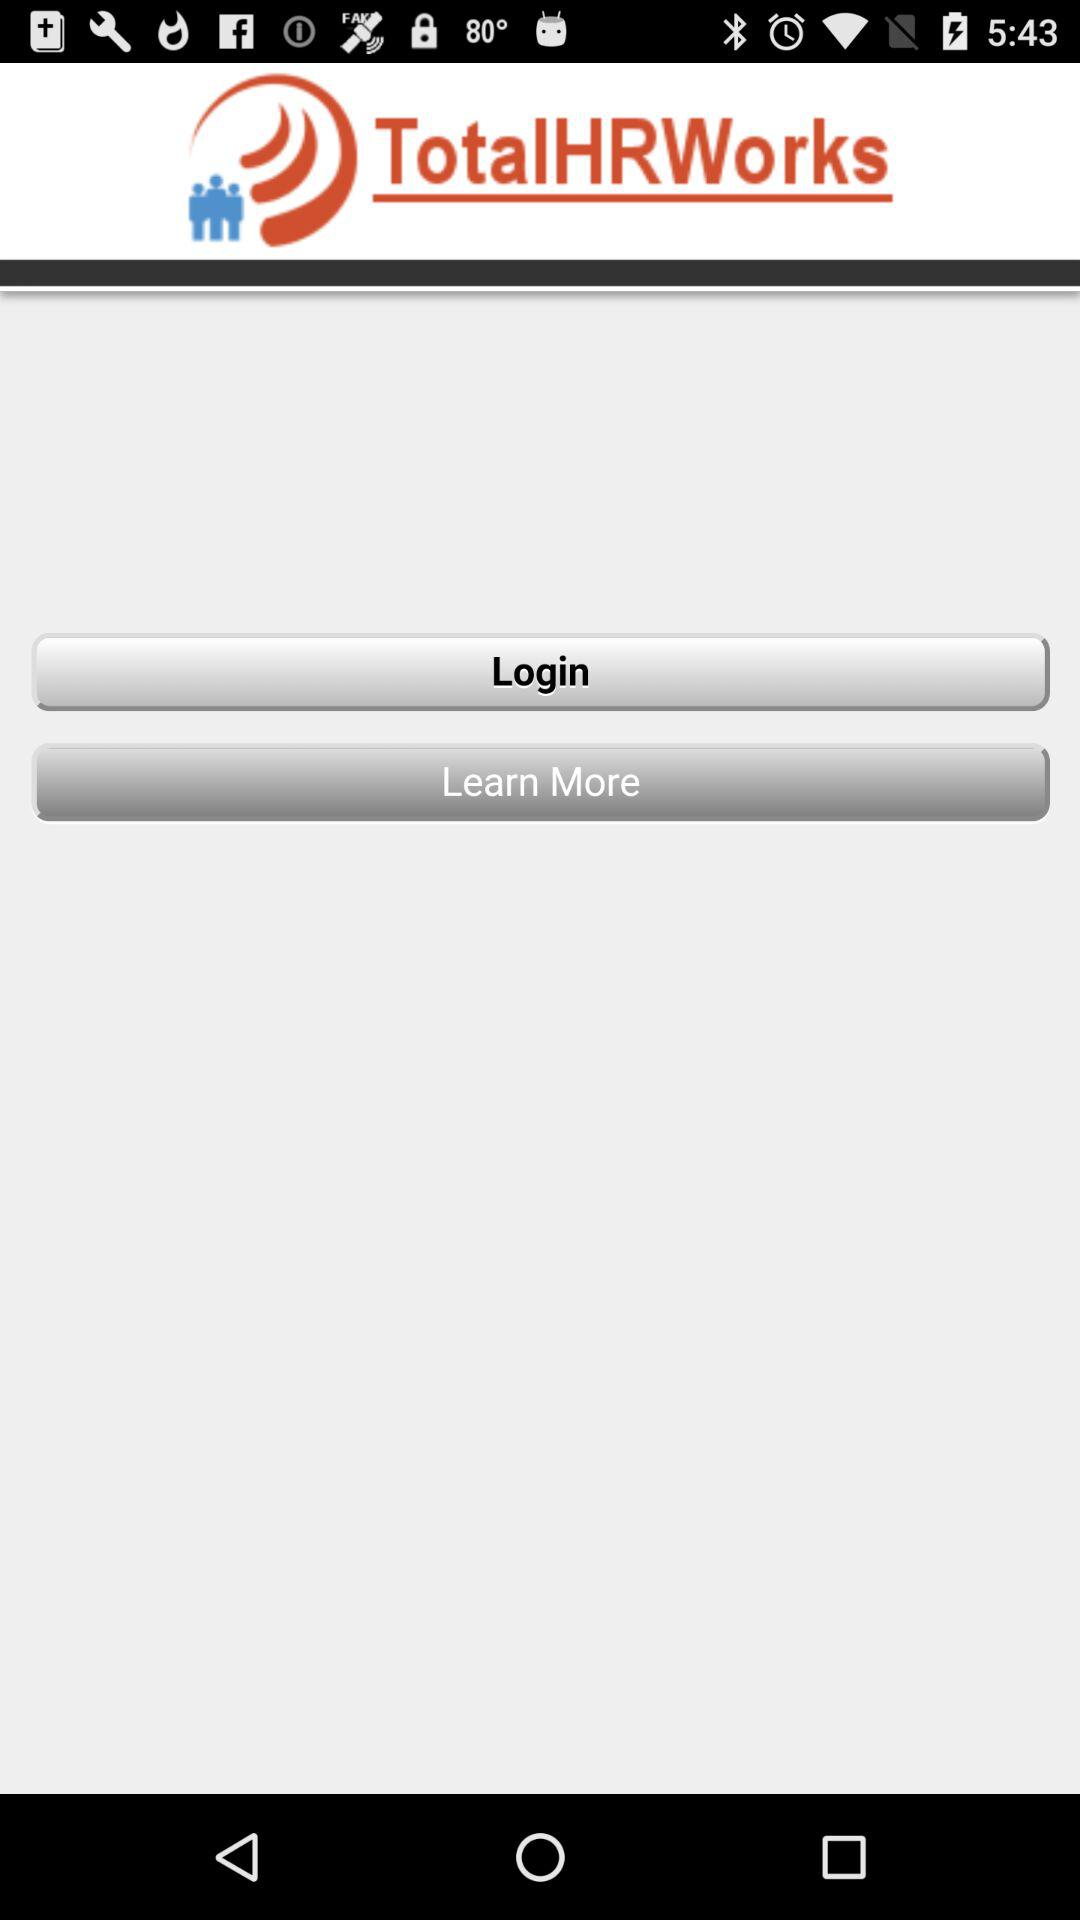What is the name of the application? The name of the application is "TotalHRWorks". 